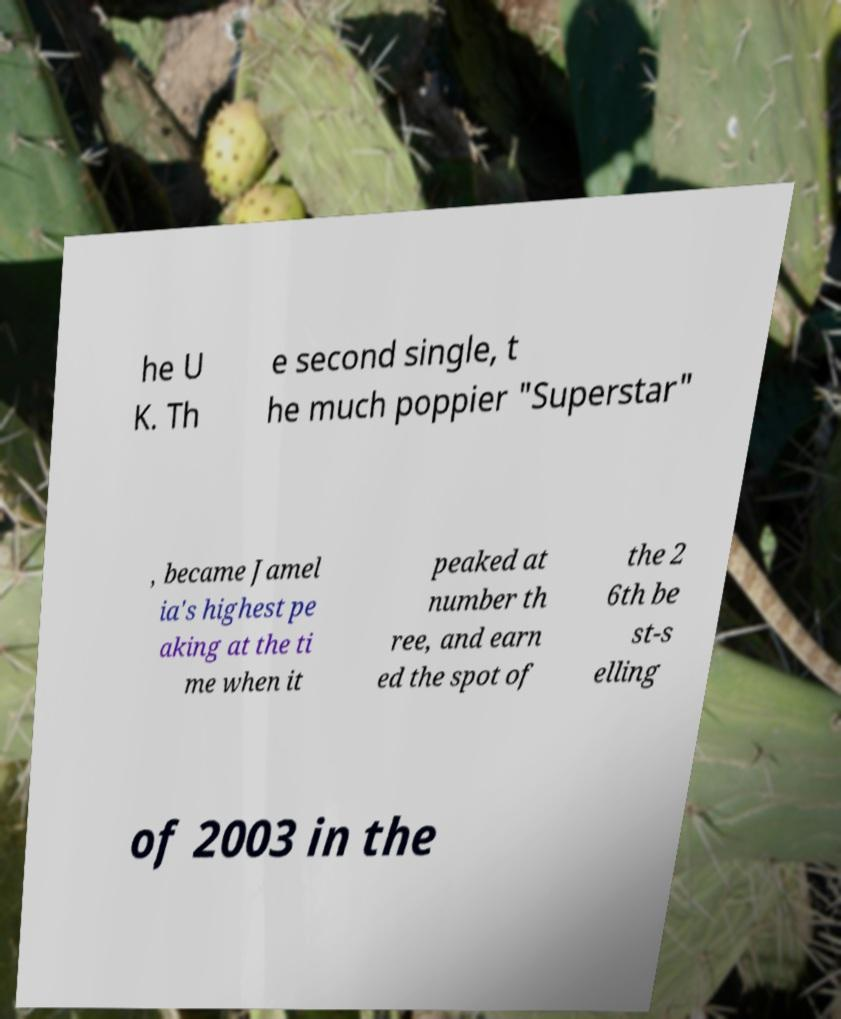Please read and relay the text visible in this image. What does it say? he U K. Th e second single, t he much poppier "Superstar" , became Jamel ia's highest pe aking at the ti me when it peaked at number th ree, and earn ed the spot of the 2 6th be st-s elling of 2003 in the 